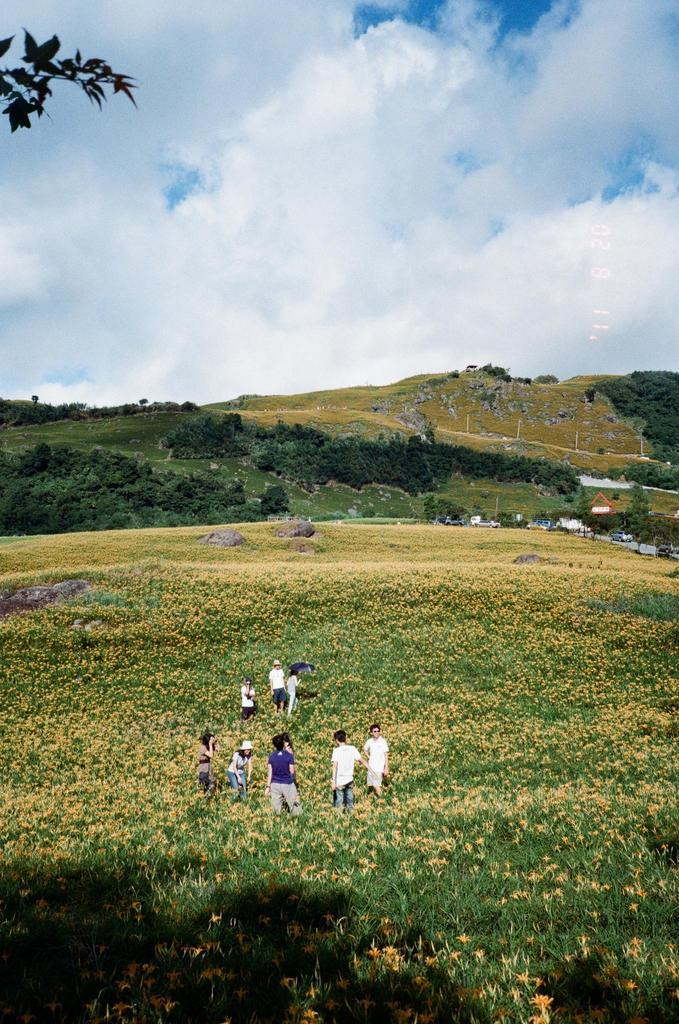What is happening in the center of the image? There are people standing in the center of the image. What type of vegetation can be seen in the image? There are plants, flowers, trees, and grass visible in the image. What can be seen in the background of the image? The sky, clouds, trees, a building, a fence, and stones are visible in the background of the image. What type of lead is being used by the people in the image? There is no lead present in the image; it features people standing amidst plants and flowers. What type of drink is being consumed by the flowers in the image? There are no drinks present in the image, as flowers do not consume drinks. 